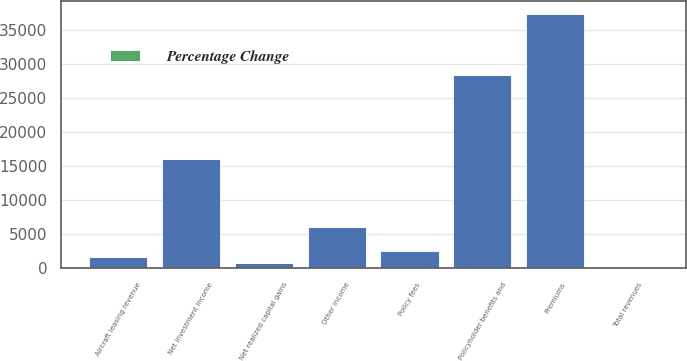Convert chart. <chart><loc_0><loc_0><loc_500><loc_500><stacked_bar_chart><ecel><fcel>Premiums<fcel>Policy fees<fcel>Net investment income<fcel>Net realized capital gains<fcel>Aircraft leasing revenue<fcel>Other income<fcel>Total revenues<fcel>Policyholder benefits and<nl><fcel>nan<fcel>37254<fcel>2615<fcel>16079<fcel>739<fcel>1602<fcel>6117<fcel>64<fcel>28281<nl><fcel>Percentage Change<fcel>1<fcel>12<fcel>2<fcel>62<fcel>64<fcel>11<fcel>6<fcel>4<nl></chart> 